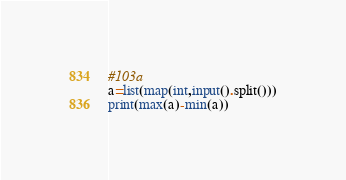Convert code to text. <code><loc_0><loc_0><loc_500><loc_500><_Python_>#103a
a=list(map(int,input().split()))
print(max(a)-min(a))</code> 